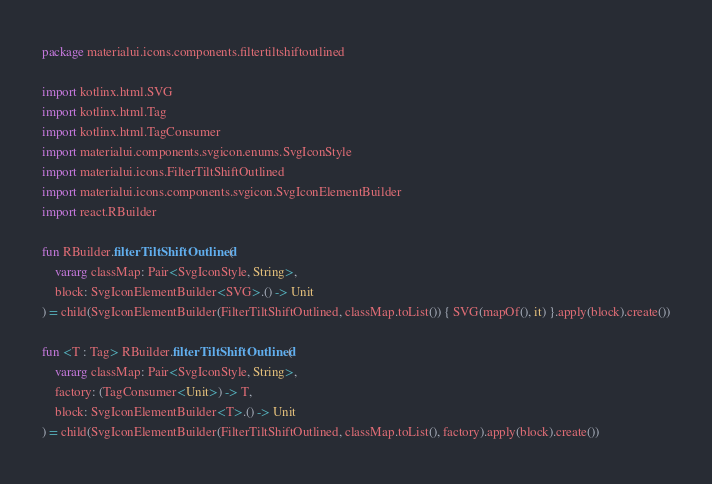Convert code to text. <code><loc_0><loc_0><loc_500><loc_500><_Kotlin_>package materialui.icons.components.filtertiltshiftoutlined

import kotlinx.html.SVG
import kotlinx.html.Tag
import kotlinx.html.TagConsumer
import materialui.components.svgicon.enums.SvgIconStyle
import materialui.icons.FilterTiltShiftOutlined
import materialui.icons.components.svgicon.SvgIconElementBuilder
import react.RBuilder

fun RBuilder.filterTiltShiftOutlined(
    vararg classMap: Pair<SvgIconStyle, String>,
    block: SvgIconElementBuilder<SVG>.() -> Unit
) = child(SvgIconElementBuilder(FilterTiltShiftOutlined, classMap.toList()) { SVG(mapOf(), it) }.apply(block).create())

fun <T : Tag> RBuilder.filterTiltShiftOutlined(
    vararg classMap: Pair<SvgIconStyle, String>,
    factory: (TagConsumer<Unit>) -> T,
    block: SvgIconElementBuilder<T>.() -> Unit
) = child(SvgIconElementBuilder(FilterTiltShiftOutlined, classMap.toList(), factory).apply(block).create())
</code> 